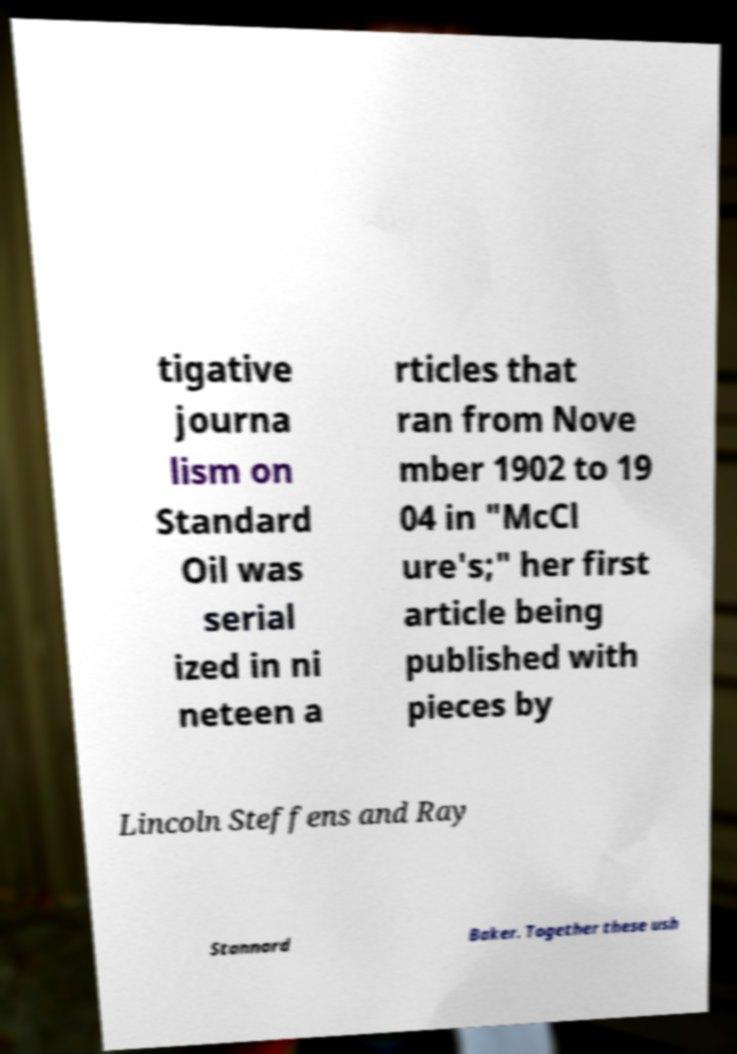Please read and relay the text visible in this image. What does it say? tigative journa lism on Standard Oil was serial ized in ni neteen a rticles that ran from Nove mber 1902 to 19 04 in "McCl ure's;" her first article being published with pieces by Lincoln Steffens and Ray Stannard Baker. Together these ush 